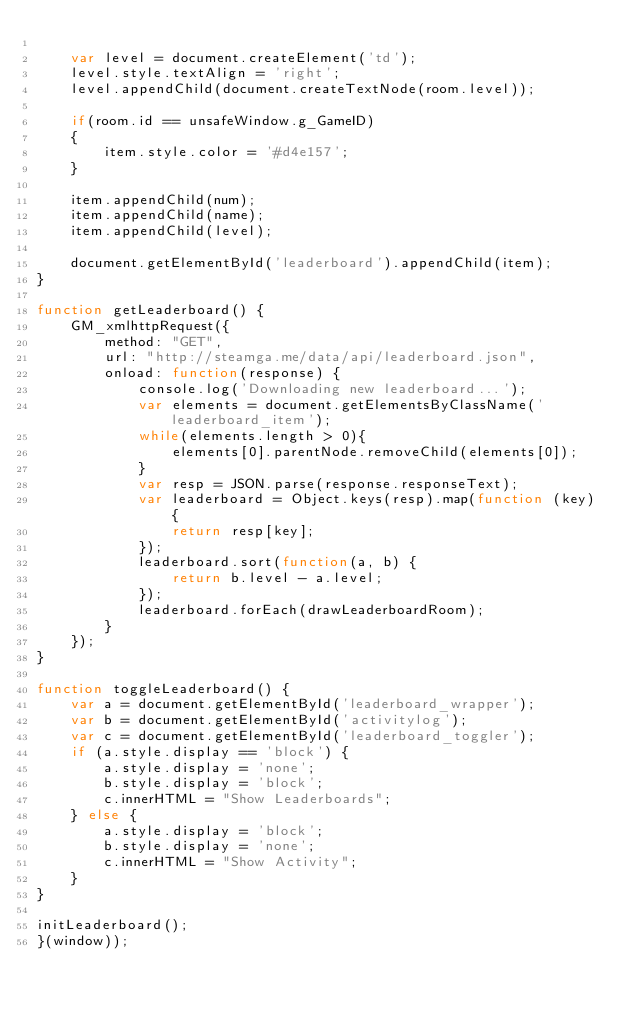<code> <loc_0><loc_0><loc_500><loc_500><_JavaScript_>
    var level = document.createElement('td');
    level.style.textAlign = 'right';
    level.appendChild(document.createTextNode(room.level));

    if(room.id == unsafeWindow.g_GameID)
    {
        item.style.color = '#d4e157';
    }

    item.appendChild(num);
    item.appendChild(name);
    item.appendChild(level);

    document.getElementById('leaderboard').appendChild(item);
}

function getLeaderboard() {
    GM_xmlhttpRequest({
        method: "GET",
        url: "http://steamga.me/data/api/leaderboard.json",
        onload: function(response) {
            console.log('Downloading new leaderboard...');
            var elements = document.getElementsByClassName('leaderboard_item');
            while(elements.length > 0){
                elements[0].parentNode.removeChild(elements[0]);
            }
            var resp = JSON.parse(response.responseText);
            var leaderboard = Object.keys(resp).map(function (key) {
            	return resp[key];
            });
            leaderboard.sort(function(a, b) {
                return b.level - a.level;
            });
            leaderboard.forEach(drawLeaderboardRoom);
        }
    });
}

function toggleLeaderboard() {
    var a = document.getElementById('leaderboard_wrapper');
    var b = document.getElementById('activitylog');
    var c = document.getElementById('leaderboard_toggler');
    if (a.style.display == 'block') {
        a.style.display = 'none';
        b.style.display = 'block';
        c.innerHTML = "Show Leaderboards";
    } else {
        a.style.display = 'block';
        b.style.display = 'none';
        c.innerHTML = "Show Activity";
    }
}

initLeaderboard();
}(window));
</code> 